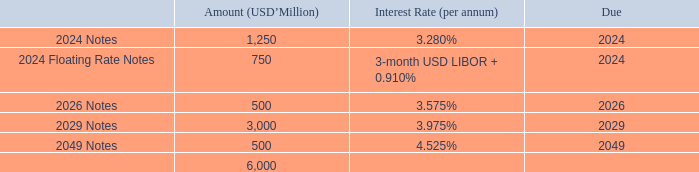NOTES PAYABLE (continued)
All of these notes payable issued by the Group were unsecured.
On 1 April 2019, the Company updated the Global Medium Term Note Programme (the “Programme”) to include, among other things, the Company’s recent corporate and financial information and increased the limit of aggregate principal amount of the notes under the Programme from USD10 billion to USD20 billion (or its equivalent in other currencies).
On 11 April 2019, the Company issued five tranches of senior notes under the Programme with an aggregate principal amount of USD6 billion as set out below.
During the year ended 31 December 2019, the notes payable with an aggregate principal amount of USD2,000 million issued in April 2014 reached their maturity and were repaid in full by the Group.
As at 31 December 2019, the fair value of the notes payable amounted to RMB98,668 million (31 December 2018: RMB62,820 million). The respective fair values are assessed based on the active market price of these notes on the reporting date or by making reference to similar instruments traded in the observable market.
How much is the aggregate principal amount of the five tranches of senior notes issued under the Programme on 11 April 2019? Usd6 billion. How much is the 2024 Notes in USD?
Answer scale should be: million. 1,250. How much is the 2026 Notes in USD?
Answer scale should be: million. 500. How many percent of the total notes payable is the 2024 Notes?
Answer scale should be: percent. 1,250/6,000
Answer: 20.83. How many percent of the total notes payable is the 2026 Notes?
Answer scale should be: percent. 500/6,000
Answer: 8.33. How many percent of the total notes payable is the 2029 Notes?
Answer scale should be: percent. 3,000/6,000
Answer: 50. 